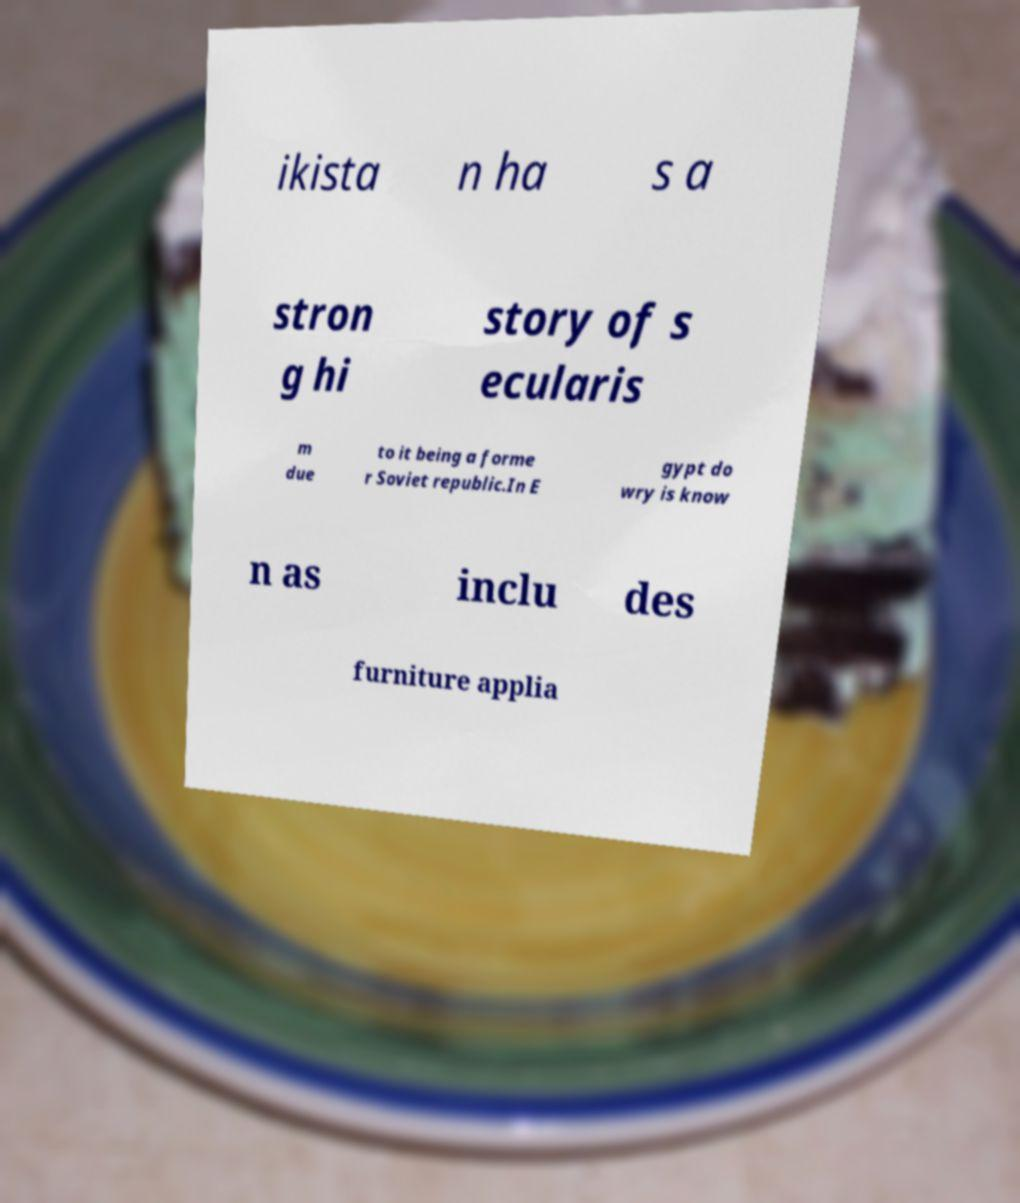Please read and relay the text visible in this image. What does it say? ikista n ha s a stron g hi story of s ecularis m due to it being a forme r Soviet republic.In E gypt do wry is know n as inclu des furniture applia 